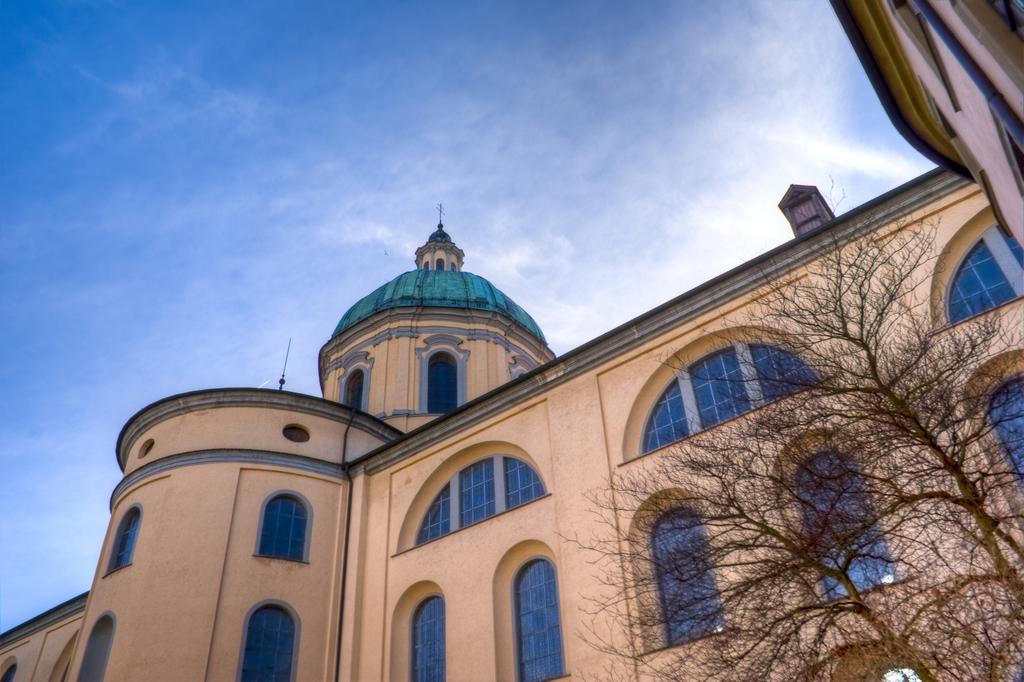Can you describe this image briefly? In the center of the image there is a building. On the right there are trees. In the background there is sky. 